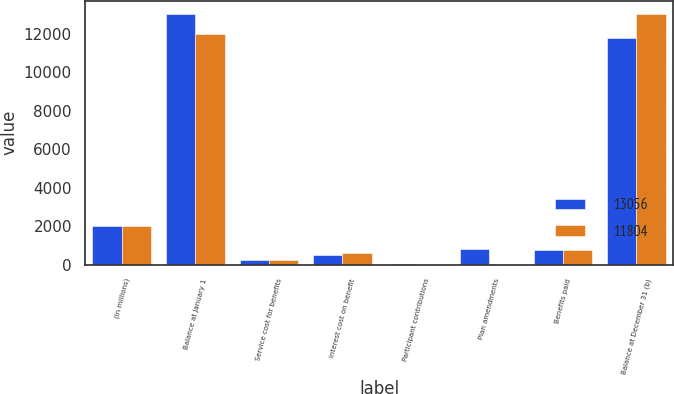Convert chart. <chart><loc_0><loc_0><loc_500><loc_500><stacked_bar_chart><ecel><fcel>(In millions)<fcel>Balance at January 1<fcel>Service cost for benefits<fcel>Interest cost on benefit<fcel>Participant contributions<fcel>Plan amendments<fcel>Benefits paid<fcel>Balance at December 31 (b)<nl><fcel>13056<fcel>2012<fcel>13056<fcel>219<fcel>491<fcel>54<fcel>832<fcel>758<fcel>11804<nl><fcel>11804<fcel>2011<fcel>12010<fcel>216<fcel>604<fcel>55<fcel>25<fcel>765<fcel>13056<nl></chart> 